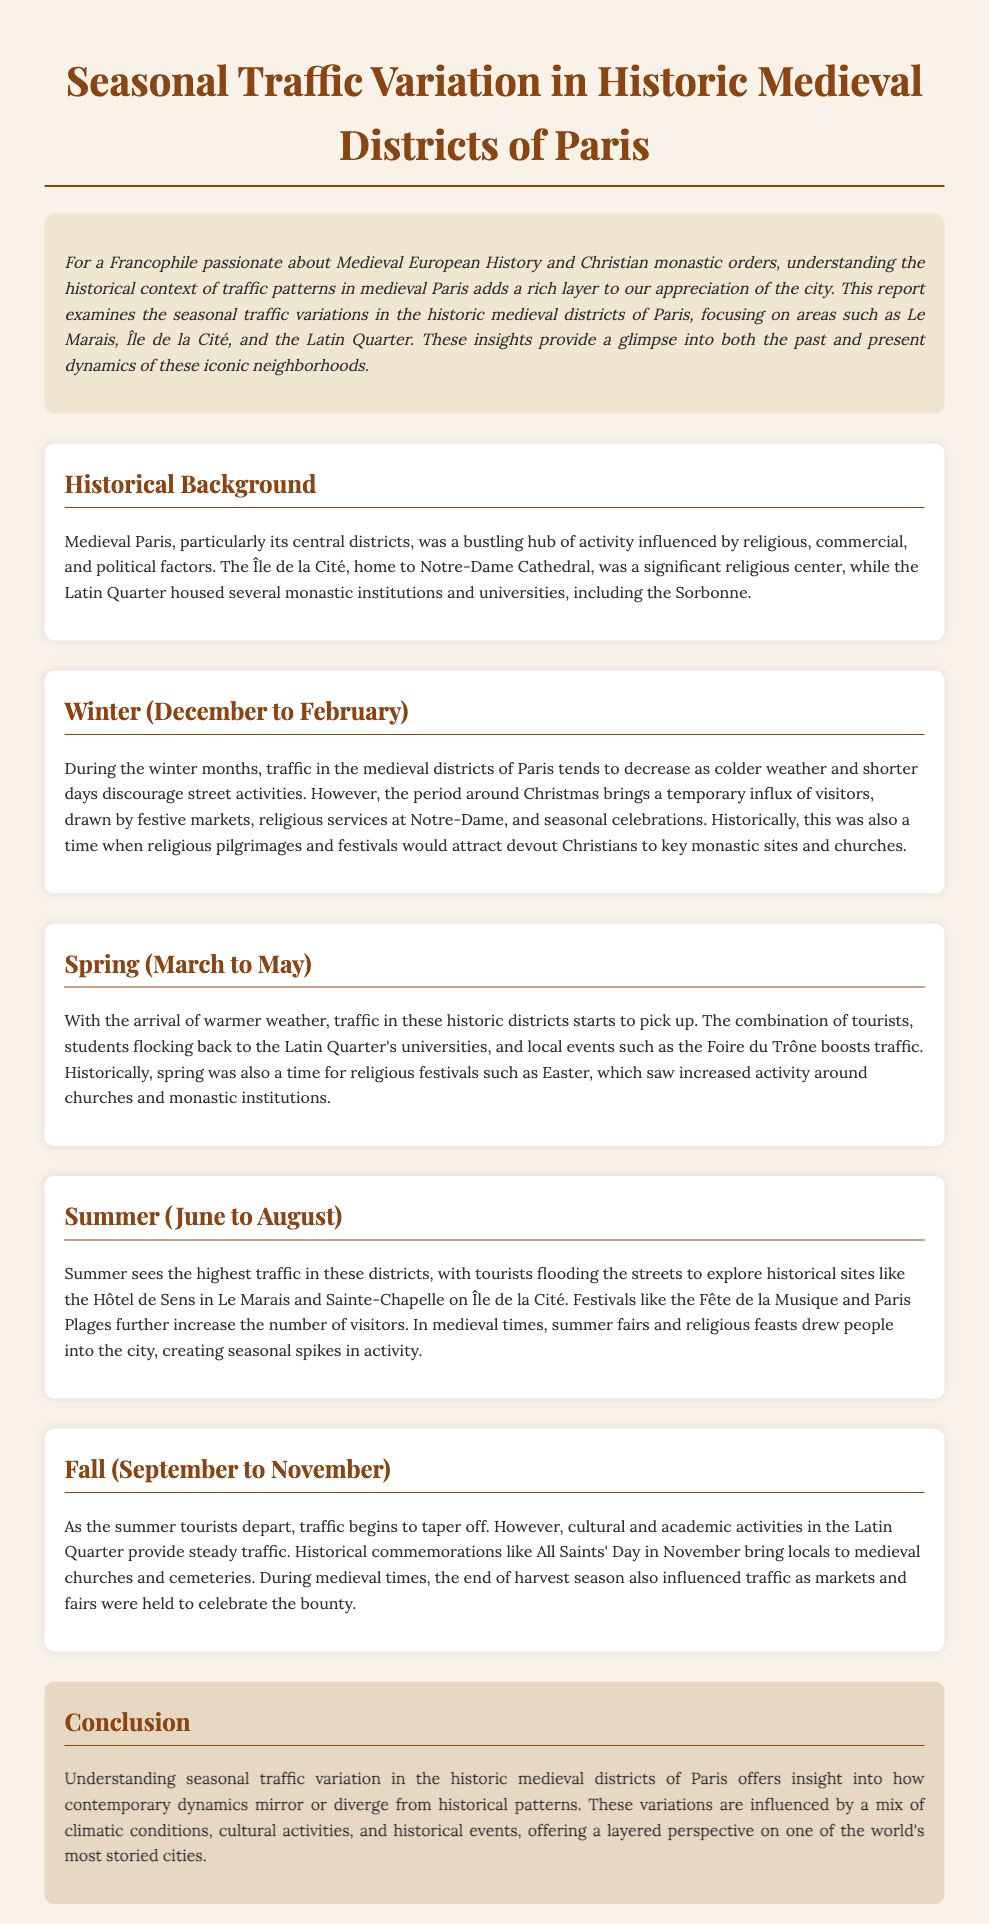What is the focus of the report? The report focuses on examining the seasonal traffic variations in the historic medieval districts of Paris.
Answer: seasonal traffic variations in historic medieval districts of Paris During which months does winter traffic occur? Winter traffic in the medieval districts of Paris occurs from December to February.
Answer: December to February Which district sees a boost in traffic during spring? The Latin Quarter sees a significant increase in traffic during the spring months.
Answer: Latin Quarter What event increases summer traffic significantly? Festivals like the Fête de la Musique significantly increase summer traffic in the medieval districts.
Answer: Fête de la Musique What marks the end of summer traffic patterns? The departure of summer tourists marks a tapering off of traffic in the fall.
Answer: Departure of summer tourists What historical activities were noted during winter in medieval times? Religious pilgrimages and festivals were significant historical activities during winter.
Answer: Religious pilgrimages and festivals Which seasonal activity attracts visitors to churches during spring? Easter is a seasonal activity that draws increased visitors to churches in the spring.
Answer: Easter What is a key influence on traffic during fall? Cultural and academic activities in the Latin Quarter are key influences on traffic during the fall.
Answer: Cultural and academic activities What is stated about climatic influence on traffic? Climatic conditions influence the seasonal variations in traffic patterns.
Answer: Climatic conditions 